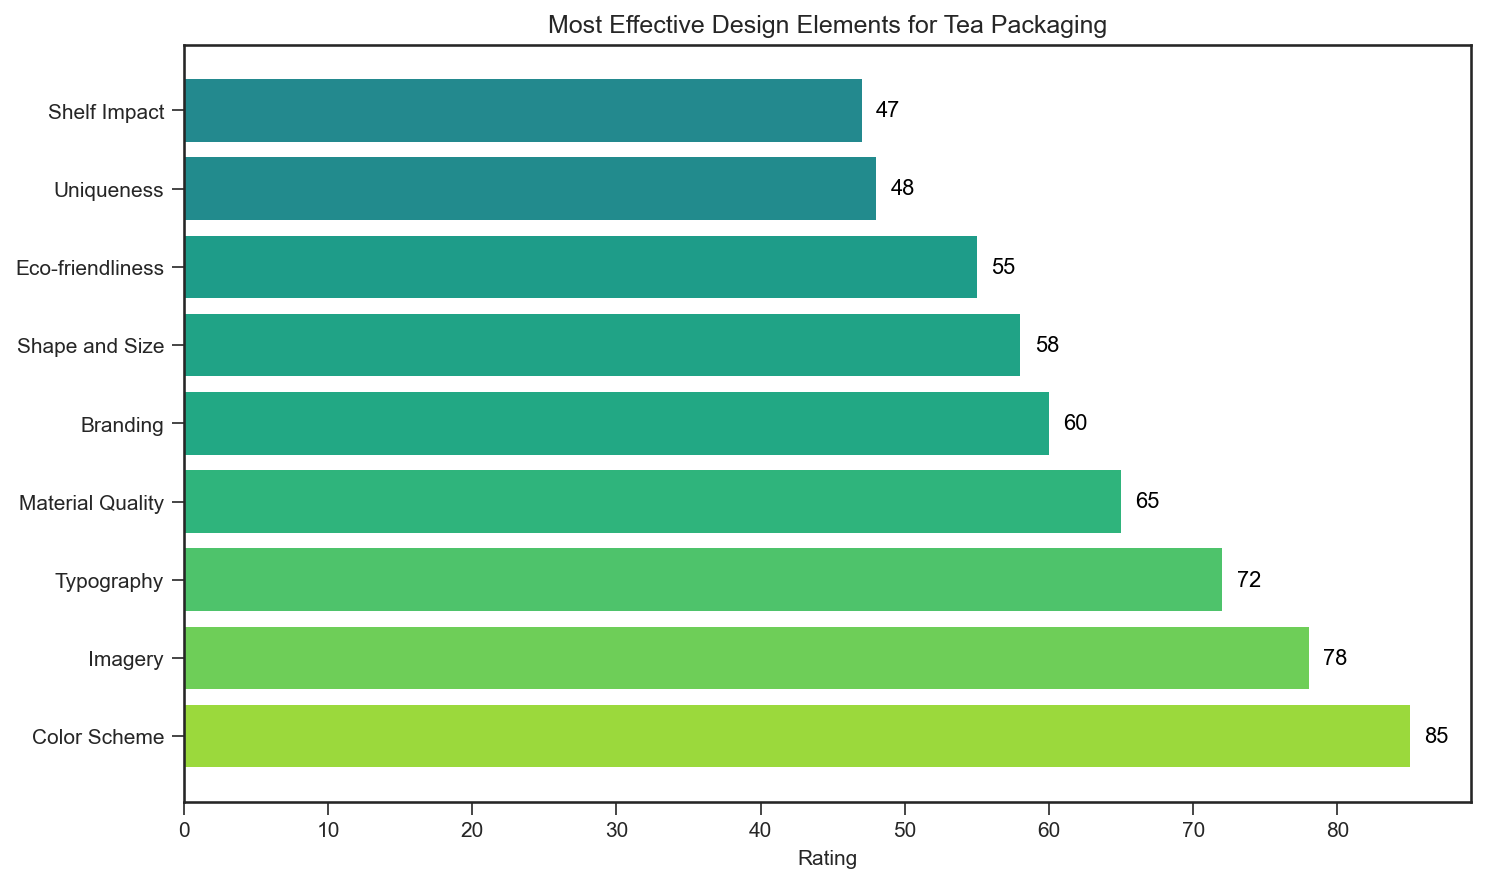What design element has the highest rating? By observing the length of the bars, the bar for "Color Scheme" is the longest and reaches the furthest on the rating scale.
Answer: Color Scheme Which design element has the lowest rating? By observing the length of the bars, the bar for "Shelf Impact" is the shortest and reaches the least on the rating scale.
Answer: Shelf Impact What is the rating difference between "Color Scheme" and "Branding"? The rating for "Color Scheme" is 85, and the rating for "Branding" is 60. The difference is 85 - 60 = 25.
Answer: 25 Is the rating for "Imagery" greater than for "Typography"? The rating for "Imagery" is 78, and the rating for "Typography" is 72. Since 78 is greater than 72, the answer is yes.
Answer: Yes What is the total rating for "Material Quality" and "Shape and Size"? The rating for "Material Quality" is 65, and the rating for "Shape and Size" is 58. The total is 65 + 58 = 123.
Answer: 123 Which design element closely follows "Imagery" in terms of rating? "Typography" follows "Imagery" in the bar chart and it is rated 72.
Answer: Typography How many design elements have a rating greater than 70? The design elements with ratings above 70 are "Color Scheme" (85), "Imagery" (78), and "Typography" (72). That makes a total of 3 elements.
Answer: 3 Is there any design element with a rating exactly equal to 55? The bar corresponding to "Eco-friendliness" has a rating of 55.
Answer: Yes Compare the ratings of "Eco-friendliness" and "Uniqueness". Which one is higher? The rating of "Eco-friendliness" is 55, while "Uniqueness" is rated at 48. Since 55 is higher than 48, "Eco-friendliness" has a higher rating.
Answer: Eco-friendliness What is the combined rating of "Shape and Size" and "Shelf Impact"? The rating for "Shape and Size" is 58, and the rating for "Shelf Impact" is 47. The combined rating is 58 + 47 = 105.
Answer: 105 